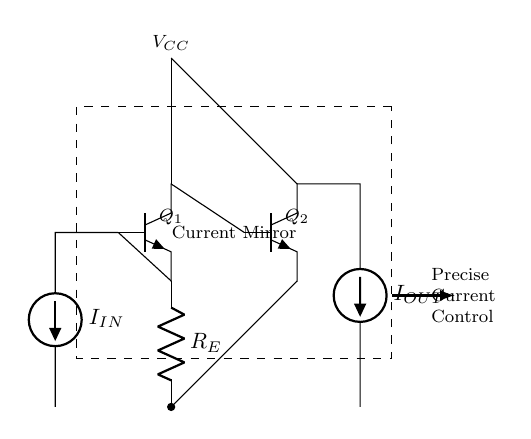What type of circuit is depicted? This circuit is a current mirror. It can be identified by the arrangement of transistors and the configuration that allows for precise current control, which is typical of current mirror circuits.
Answer: Current mirror What components are present in this circuit? The circuit contains two transistors (Q1 and Q2), a resistor (R_E), and two current sources (I_IN and I_OUT). The current mirror utilizes these elements to create a controlled current output based on an input current.
Answer: Transistors, resistor, current sources What is the role of resistor R_E in this circuit? Resistor R_E is used for setting the emitter current in transistor Q1, which in turn establishes the reference current for the current mirror operation. It affects the overall current flowing through the circuit.
Answer: Sets emitter current What is the relationship between I_IN and I_OUT? They are approximately equal in a properly functioning current mirror, due to the mirroring effect established by the transistors Q1 and Q2, ensuring that the output current is a replica of the input current.
Answer: Approximately equal If V_CC is 10V, what happens to the output current I_OUT? If V_CC increases, and the rest of the circuit remains unchanged, I_OUT can increase, given that the current mirror is functioning within its limits and the supply voltage does not exceed the breakdown voltages of the transistors. However, the actual relationship requires additional information about the circuit configuration and transistor parameters.
Answer: Can increase What is the primary application of this current mirror circuit? The current mirror is commonly used for biasing and providing stable operating currents in various analog circuits such as amplifiers. It serves the purpose of ensuring consistency in current levels, even with variations in voltage and temperature.
Answer: Biasing in amplifiers 